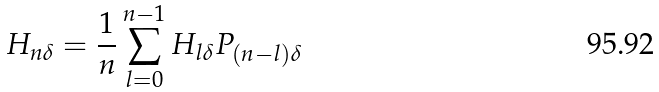Convert formula to latex. <formula><loc_0><loc_0><loc_500><loc_500>H _ { n \delta } = \frac { 1 } { n } \sum _ { l = 0 } ^ { n - 1 } H _ { l \delta } P _ { ( n - l ) \delta }</formula> 